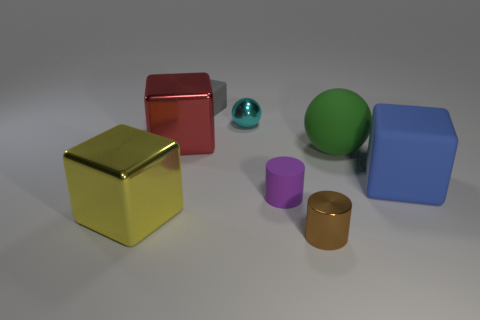The metal cylinder is what size?
Give a very brief answer. Small. What number of blue matte cubes have the same size as the blue matte object?
Your answer should be very brief. 0. There is a small cyan object that is the same shape as the large green object; what is it made of?
Your response must be concise. Metal. There is a big object that is behind the small purple rubber cylinder and on the left side of the large matte ball; what shape is it?
Give a very brief answer. Cube. What is the shape of the tiny metal object that is in front of the red object?
Make the answer very short. Cylinder. What number of objects are both left of the cyan shiny thing and behind the large red cube?
Your response must be concise. 1. There is a brown metallic cylinder; is it the same size as the rubber block left of the large matte block?
Your answer should be compact. Yes. There is a metallic cube on the right side of the big thing that is left of the big metallic cube behind the big rubber ball; how big is it?
Provide a short and direct response. Large. How big is the shiny thing on the right side of the small purple object?
Offer a terse response. Small. The other big thing that is made of the same material as the green thing is what shape?
Your response must be concise. Cube. 